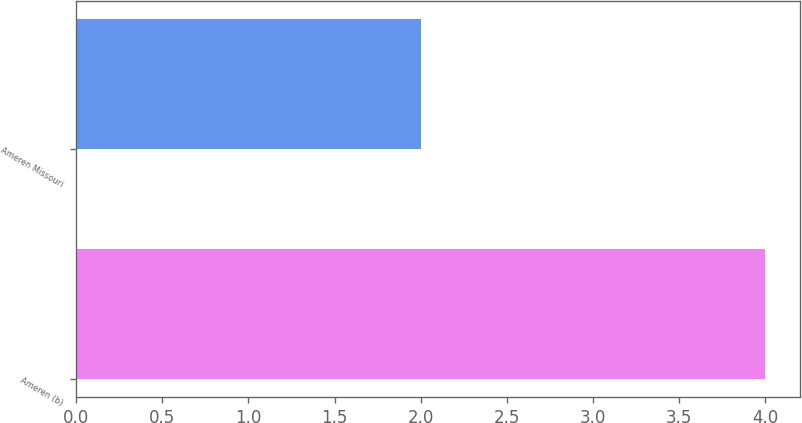Convert chart. <chart><loc_0><loc_0><loc_500><loc_500><bar_chart><fcel>Ameren (b)<fcel>Ameren Missouri<nl><fcel>4<fcel>2<nl></chart> 